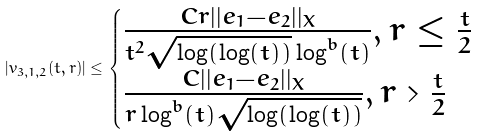Convert formula to latex. <formula><loc_0><loc_0><loc_500><loc_500>| v _ { 3 , 1 , 2 } ( t , r ) | \leq \begin{cases} \frac { C r | | e _ { 1 } - e _ { 2 } | | _ { X } } { t ^ { 2 } \sqrt { \log ( \log ( t ) ) } \log ^ { b } ( t ) } , r \leq \frac { t } { 2 } \\ \frac { C | | e _ { 1 } - e _ { 2 } | | _ { X } } { r \log ^ { b } ( t ) \sqrt { \log ( \log ( t ) ) } } , r > \frac { t } { 2 } \end{cases}</formula> 